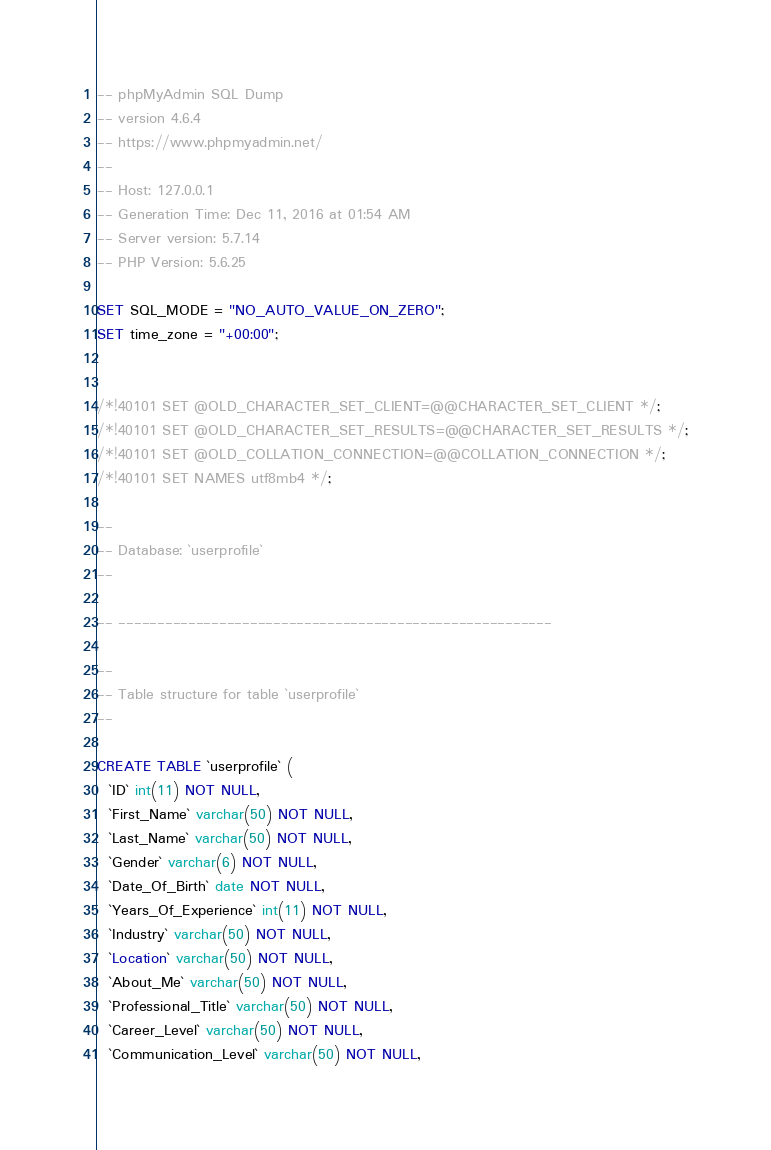Convert code to text. <code><loc_0><loc_0><loc_500><loc_500><_SQL_>-- phpMyAdmin SQL Dump
-- version 4.6.4
-- https://www.phpmyadmin.net/
--
-- Host: 127.0.0.1
-- Generation Time: Dec 11, 2016 at 01:54 AM
-- Server version: 5.7.14
-- PHP Version: 5.6.25

SET SQL_MODE = "NO_AUTO_VALUE_ON_ZERO";
SET time_zone = "+00:00";


/*!40101 SET @OLD_CHARACTER_SET_CLIENT=@@CHARACTER_SET_CLIENT */;
/*!40101 SET @OLD_CHARACTER_SET_RESULTS=@@CHARACTER_SET_RESULTS */;
/*!40101 SET @OLD_COLLATION_CONNECTION=@@COLLATION_CONNECTION */;
/*!40101 SET NAMES utf8mb4 */;

--
-- Database: `userprofile`
--

-- --------------------------------------------------------

--
-- Table structure for table `userprofile`
--

CREATE TABLE `userprofile` (
  `ID` int(11) NOT NULL,
  `First_Name` varchar(50) NOT NULL,
  `Last_Name` varchar(50) NOT NULL,
  `Gender` varchar(6) NOT NULL,
  `Date_Of_Birth` date NOT NULL,
  `Years_Of_Experience` int(11) NOT NULL,
  `Industry` varchar(50) NOT NULL,
  `Location` varchar(50) NOT NULL,
  `About_Me` varchar(50) NOT NULL,
  `Professional_Title` varchar(50) NOT NULL,
  `Career_Level` varchar(50) NOT NULL,
  `Communication_Level` varchar(50) NOT NULL,</code> 